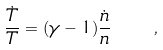Convert formula to latex. <formula><loc_0><loc_0><loc_500><loc_500>\frac { \dot { T } } { T } = ( \gamma - 1 ) \frac { \dot { n } } { n } \quad ,</formula> 